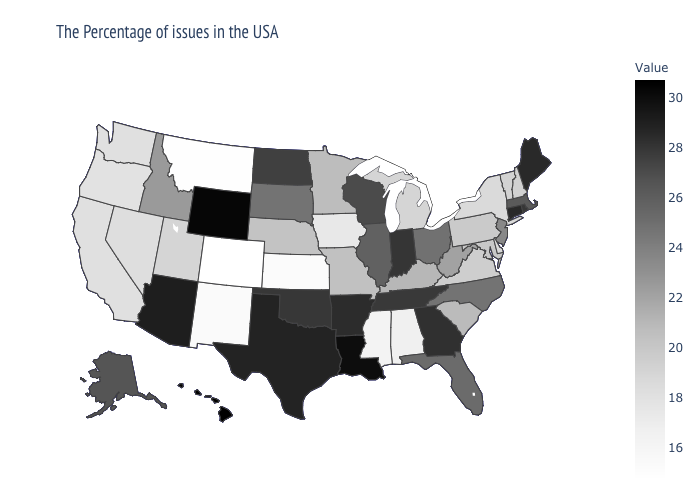Among the states that border Missouri , does Kansas have the lowest value?
Be succinct. Yes. Does North Carolina have a lower value than Maine?
Keep it brief. Yes. Does Kansas have the lowest value in the MidWest?
Write a very short answer. Yes. Is the legend a continuous bar?
Concise answer only. Yes. Which states hav the highest value in the South?
Write a very short answer. Louisiana. 